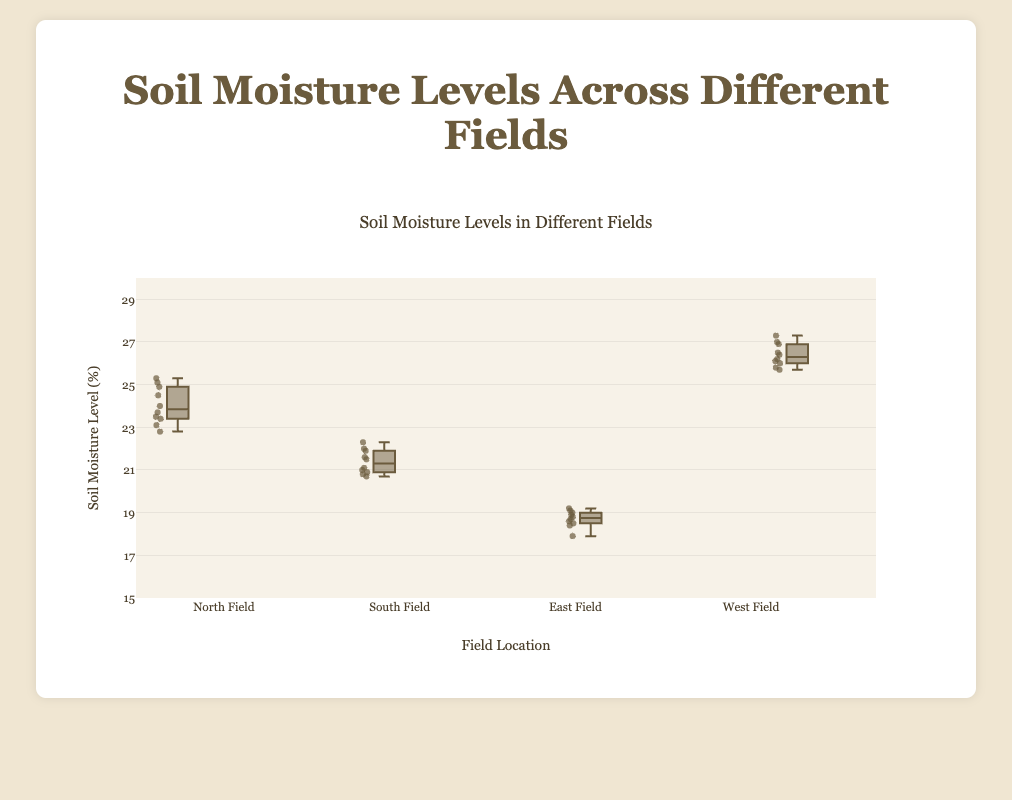What is the title of the figure? The title of the figure is generally found at the top of the chart and indicates what the figure represents.
Answer: Soil Moisture Levels in Different Fields Which field has the highest median soil moisture level? The median value is the line inside the box. By looking at the boxes, identify which one has the highest line within it.
Answer: West Field What is the interquartile range (IQR) for the North Field? The IQR is the difference between the third quartile (top edge of the box) and the first quartile (bottom edge of the box).
Answer: 24.6 - 23.4 = 1.2 How does the spread of soil moisture levels in the East Field compare to the South Field? The spread can be observed by comparing the sizes of the boxes and whiskers. The East Field's box and whiskers length indicate its spread, similarly for the South Field.
Answer: East Field has a smaller spread compared to South Field Which field has the smallest range of soil moisture levels? The smallest range can be determined by finding which box plot has the shortest total length from its whiskers' ends.
Answer: East Field Between the North Field and South Field, which one exhibits more variability in soil moisture levels? Examining the length of the boxes and whiskers helps determine variability. Longer boxes and whiskers indicate more variability.
Answer: North Field What is the median soil moisture level in the South Field? The median is represented by the line inside the box. Check where the line falls in the South Field's box plot.
Answer: Approximately 21.4 Which field has the highest maximum soil moisture level? The maximum value is denoted by the top whisker of each box plot. Identify the highest top whisker.
Answer: West Field Is there any field that contains any outliers in its soil moisture levels? Outliers are typically marked as individual points outside the whiskers of a box plot. Check each field for these points.
Answer: No outliers are present evidenced by single point markers outside the whisker range Compare the median soil moisture levels of North and West fields. Which one is higher and by how much? Compare the median lines of both fields' box plots to see which is higher and calculate the difference.
Answer: West Field's median is higher by 1.5 (West Field: ≈26.5, North Field: ≈25) 